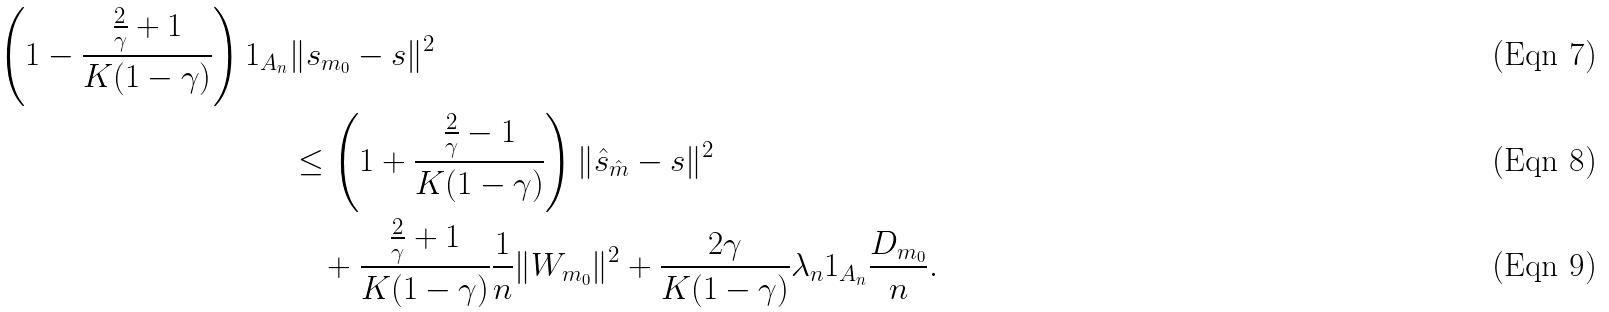<formula> <loc_0><loc_0><loc_500><loc_500>\left ( 1 - \frac { \frac { 2 } { \gamma } + 1 } { K ( 1 - \gamma ) } \right ) 1 _ { A _ { n } } & \| s _ { m _ { 0 } } - s \| ^ { 2 } \\ & \leq \left ( 1 + \frac { \frac { 2 } { \gamma } - 1 } { K ( 1 - \gamma ) } \right ) \| \hat { s } _ { \hat { m } } - s \| ^ { 2 } \\ & \quad + \frac { \frac { 2 } { \gamma } + 1 } { K ( 1 - \gamma ) } \frac { 1 } { n } \| W _ { m _ { 0 } } \| ^ { 2 } + \frac { 2 \gamma } { K ( 1 - \gamma ) } \lambda _ { n } 1 _ { A _ { n } } \frac { D _ { m _ { 0 } } } { n } .</formula> 